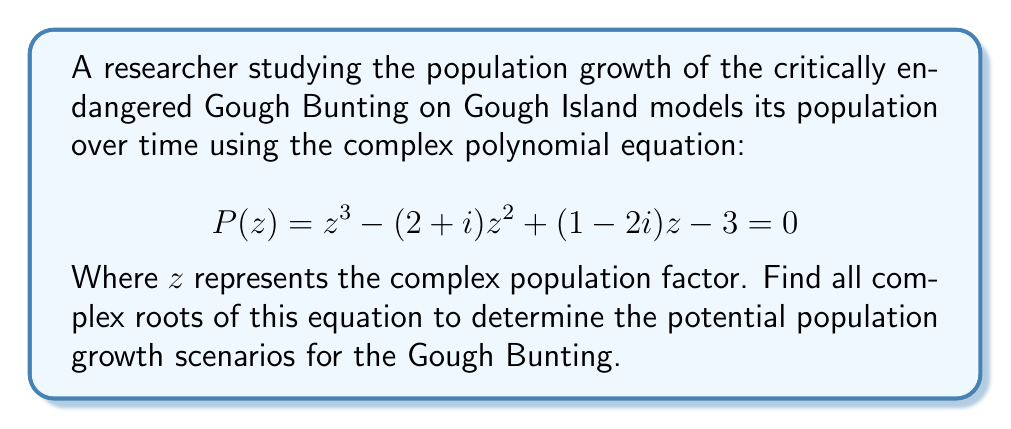Help me with this question. To find the complex roots of this cubic equation, we'll use the following steps:

1) First, we'll use the cubic formula to solve for the roots. The general form of a cubic equation is:

   $$az^3 + bz^2 + cz + d = 0$$

   In our case, $a=1$, $b=-(2+i)$, $c=(1-2i)$, and $d=-3$.

2) We calculate the following intermediary values:

   $p = \frac{3ac-b^2}{3a^2} = \frac{3(1)(1-2i)-(-2-i)^2}{3(1)^2} = \frac{3-6i-4-4i+1}{3} = -\frac{1}{3}-\frac{10i}{3}$

   $q = \frac{2b^3-9abc+27a^2d}{27a^3} = \frac{2(-2-i)^3-9(1)(-2-i)(1-2i)+27(1)^2(-3)}{27(1)^3}$
      $= \frac{-8-12i+1-3i+18+36i-81}{27} = -\frac{70}{27}+\frac{21i}{27}$

3) Now we calculate:

   $D = (\frac{q}{2})^2 + (\frac{p}{3})^3 = (\frac{-35+21i}{54})^2 + (-\frac{1}{9}-\frac{10i}{9})^3$

4) The roots are given by:

   $z_k = -\frac{b}{3a} + (S+T)\omega^k + \frac{p}{3(S+T)}\omega^{2k}$

   Where $k = 0, 1, 2$, $\omega = e^{2\pi i/3} = -\frac{1}{2}+\frac{\sqrt{3}}{2}i$, and

   $S = \sqrt[3]{-\frac{q}{2}+\sqrt{D}}$, $T = \sqrt[3]{-\frac{q}{2}-\sqrt{D}}$

5) Calculating these values numerically (as they are complex), we get:

   $z_0 \approx 2.2071 + 0.3714i$
   $z_1 \approx -0.1035 + 1.3143i$
   $z_2 \approx -0.1035 - 1.3143i$

These complex roots represent different scenarios for the population growth factor of the Gough Bunting.
Answer: $z_1 \approx 2.2071 + 0.3714i$, $z_2 \approx -0.1035 + 1.3143i$, $z_3 \approx -0.1035 - 1.3143i$ 